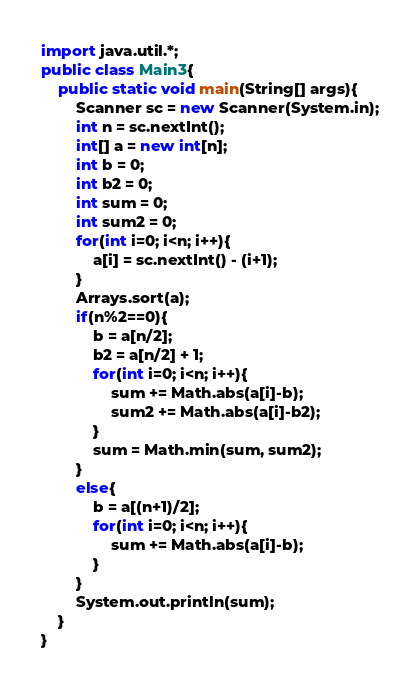Convert code to text. <code><loc_0><loc_0><loc_500><loc_500><_Java_>import java.util.*;
public class Main3{
	public static void main(String[] args){
    	Scanner sc = new Scanner(System.in);
      	int n = sc.nextInt();
      	int[] a = new int[n];
      	int b = 0;
      	int b2 = 0;
      	int sum = 0;
      	int sum2 = 0;
      	for(int i=0; i<n; i++){
        	a[i] = sc.nextInt() - (i+1);
        }
      	Arrays.sort(a);
      	if(n%2==0){
        	b = a[n/2];
          	b2 = a[n/2] + 1;
          	for(int i=0; i<n; i++){
            	sum += Math.abs(a[i]-b);
              	sum2 += Math.abs(a[i]-b2);
            }
          	sum = Math.min(sum, sum2);
        }
      	else{
        	b = a[(n+1)/2];
          	for(int i=0; i<n; i++){
            	sum += Math.abs(a[i]-b);
            }
        }
      	System.out.println(sum);
    }
}
</code> 